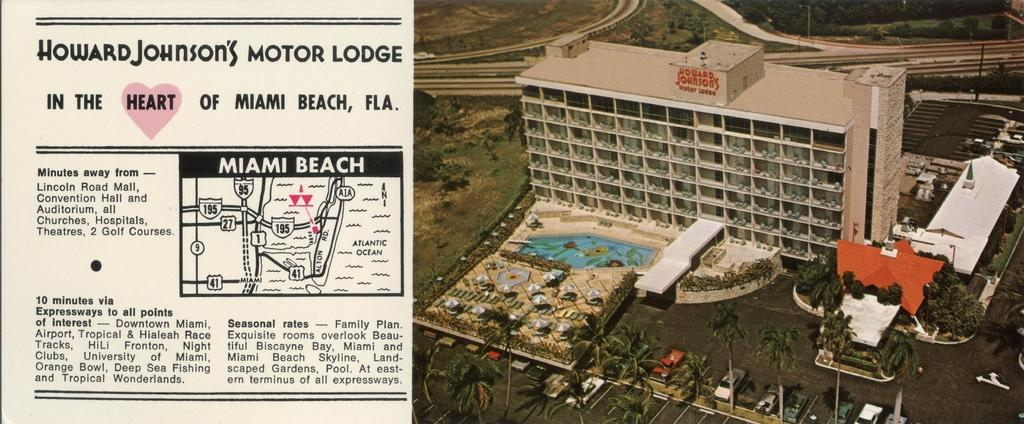What is located on the left side of the image? There is a map on the left side of the image. What can be seen on the right side of the image? There are buildings, trees, vehicles, poles, roads, a swimming pool, and umbrellas on the right side of the image. Can you describe the type of structures present on the right side of the image? The buildings are visible on the right side of the image. What type of transportation is present on the right side of the image? Vehicles are present on the right side of the image. What type of recreational feature is present on the right side of the image? There is a swimming pool on the right side of the image. What type of shade provider is present on the right side of the image? Umbrellas are present on the right side of the image. What type of crack can be seen in the image? There is no crack present in the image. What type of whip is being used by the person in the image? There is no person or whip present in the image. What type of apple is being eaten by the person in the image? There is no person or apple present in the image. 